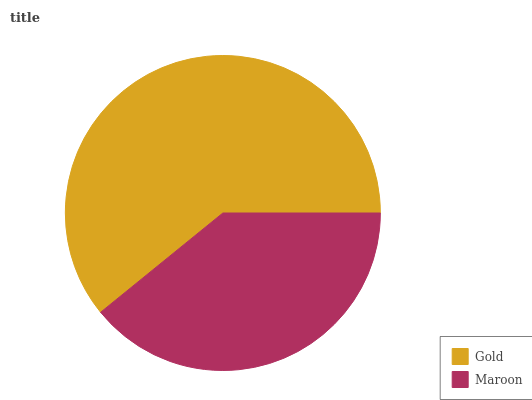Is Maroon the minimum?
Answer yes or no. Yes. Is Gold the maximum?
Answer yes or no. Yes. Is Maroon the maximum?
Answer yes or no. No. Is Gold greater than Maroon?
Answer yes or no. Yes. Is Maroon less than Gold?
Answer yes or no. Yes. Is Maroon greater than Gold?
Answer yes or no. No. Is Gold less than Maroon?
Answer yes or no. No. Is Gold the high median?
Answer yes or no. Yes. Is Maroon the low median?
Answer yes or no. Yes. Is Maroon the high median?
Answer yes or no. No. Is Gold the low median?
Answer yes or no. No. 